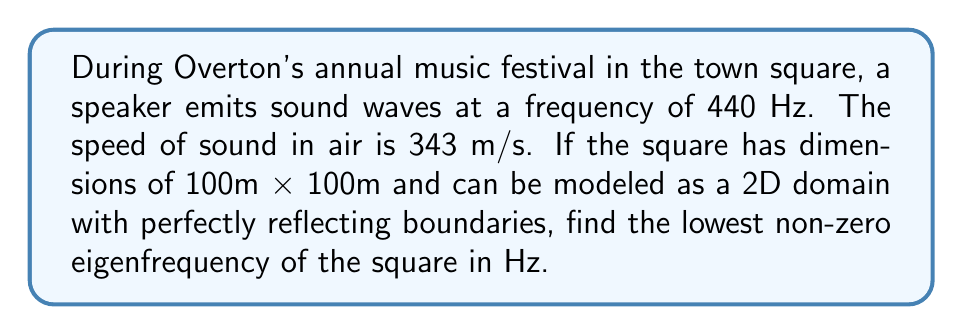Teach me how to tackle this problem. To solve this problem, we'll follow these steps:

1) The wave equation for sound propagation in 2D is:

   $$\frac{\partial^2 u}{\partial t^2} = c^2 \left(\frac{\partial^2 u}{\partial x^2} + \frac{\partial^2 u}{\partial y^2}\right)$$

   where $c$ is the speed of sound.

2) For a rectangular domain with perfectly reflecting boundaries, the solution takes the form:

   $$u(x,y,t) = \cos(\omega t) \cos(\frac{n\pi x}{L_x}) \cos(\frac{m\pi y}{L_y})$$

   where $L_x$ and $L_y$ are the dimensions of the rectangle, and $n$ and $m$ are non-negative integers.

3) The eigenfrequencies are given by:

   $$f_{n,m} = \frac{c}{2} \sqrt{\left(\frac{n}{L_x}\right)^2 + \left(\frac{m}{L_y}\right)^2}$$

4) In our case, $L_x = L_y = 100$ m, and $c = 343$ m/s.

5) The lowest non-zero eigenfrequency occurs when either $n$ or $m$ is 1 and the other is 0. So, we calculate:

   $$f_{1,0} = f_{0,1} = \frac{343}{2} \sqrt{\left(\frac{1}{100}\right)^2 + \left(\frac{0}{100}\right)^2} = \frac{343}{200} = 1.715 \text{ Hz}$$

6) Rounding to three decimal places, we get 1.715 Hz.
Answer: 1.715 Hz 